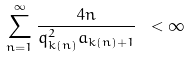Convert formula to latex. <formula><loc_0><loc_0><loc_500><loc_500>\sum _ { n = 1 } ^ { \infty } \frac { 4 n } { q ^ { 2 } _ { k ( n ) } a _ { k ( n ) + 1 } } \ < \infty</formula> 